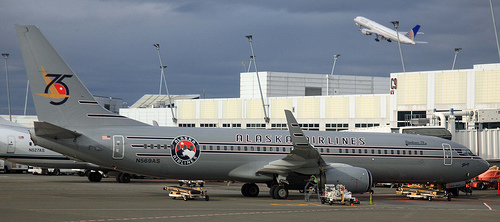Does the image suggest any activity happening soon on the plane? Given the presence of ground support vehicles near the aircraft, it suggests that there may be activity related to loading or unloading luggage, or preparing the aircraft for departure. Is there any indication of the weather conditions at the time the photo was taken? The clouds in the background along with the wet ground suggest that it may be partly cloudy or that there has been recent rain. 